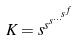<formula> <loc_0><loc_0><loc_500><loc_500>K = s ^ { s ^ { s ^ { \dots ^ { s ^ { f } } } } }</formula> 